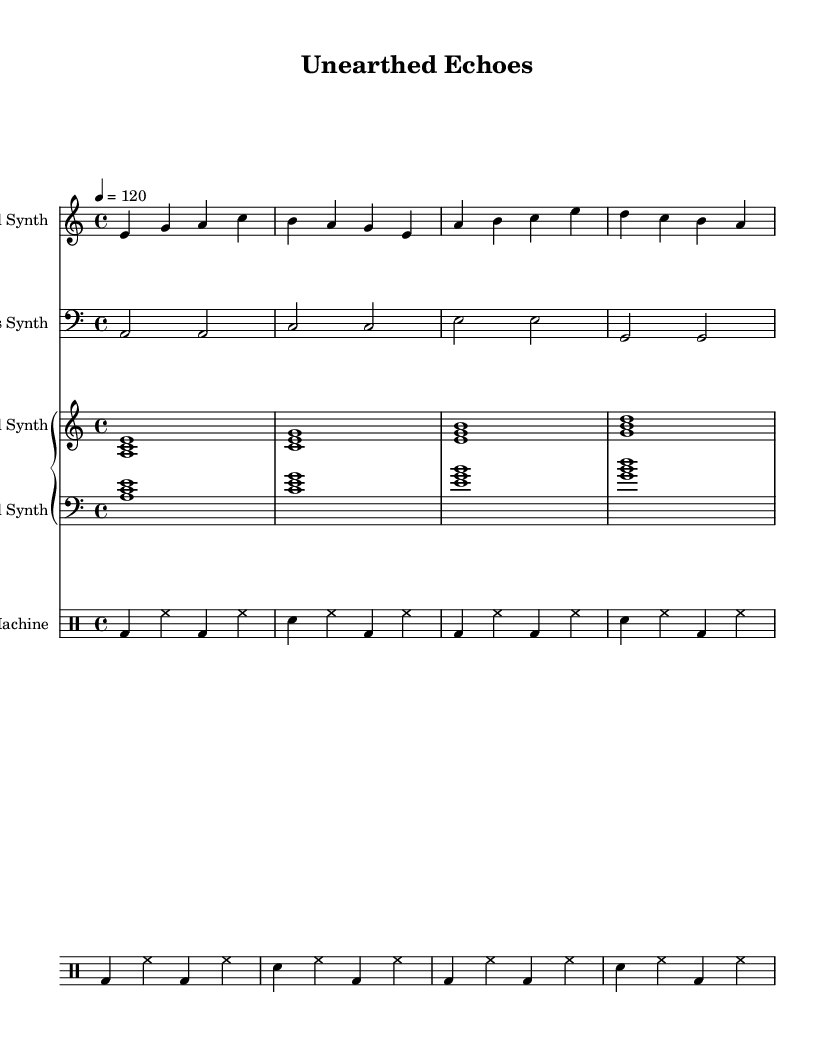what is the key signature of this music? The key signature is indicated by the placement of sharps or flats at the beginning of the staff. In this piece, there are no sharps or flats shown, which indicates it is in A minor.
Answer: A minor what is the time signature of this music? The time signature is specified right after the key signature. Here, it shows 4/4, which indicates that there are four beats in each measure.
Answer: 4/4 what is the tempo of this composition? The tempo is indicated at the beginning of the score by the marking "4 = 120," meaning it is set at 120 beats per minute.
Answer: 120 how many measures are in the lead synth part? By counting the number of vertical lines (bar lines) in the lead synth part, I can see there are four measures in total.
Answer: 4 what type of synthesizer is used for the lead part? The instrument name set at the start of the lead synth staff indicates it uses a "Lead Synth."
Answer: Lead Synth which synth plays the bass notes? The bass notes are notated in the bass staff, which is marked as "Bass Synth," indicating it plays the bass parts.
Answer: Bass Synth how is the rhythm structured in the drum machine part? The drum machine part indicates a repeated pattern of bass drum and snare, each followed by hi-hats, with a consistent 4:4 time signature throughout. This demonstrates a typical rhythmic structure in electronic music for driving the beat.
Answer: Repeated pattern 